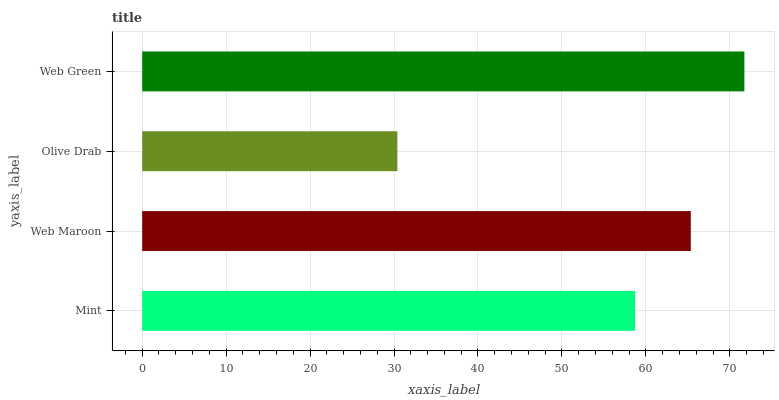Is Olive Drab the minimum?
Answer yes or no. Yes. Is Web Green the maximum?
Answer yes or no. Yes. Is Web Maroon the minimum?
Answer yes or no. No. Is Web Maroon the maximum?
Answer yes or no. No. Is Web Maroon greater than Mint?
Answer yes or no. Yes. Is Mint less than Web Maroon?
Answer yes or no. Yes. Is Mint greater than Web Maroon?
Answer yes or no. No. Is Web Maroon less than Mint?
Answer yes or no. No. Is Web Maroon the high median?
Answer yes or no. Yes. Is Mint the low median?
Answer yes or no. Yes. Is Mint the high median?
Answer yes or no. No. Is Web Maroon the low median?
Answer yes or no. No. 